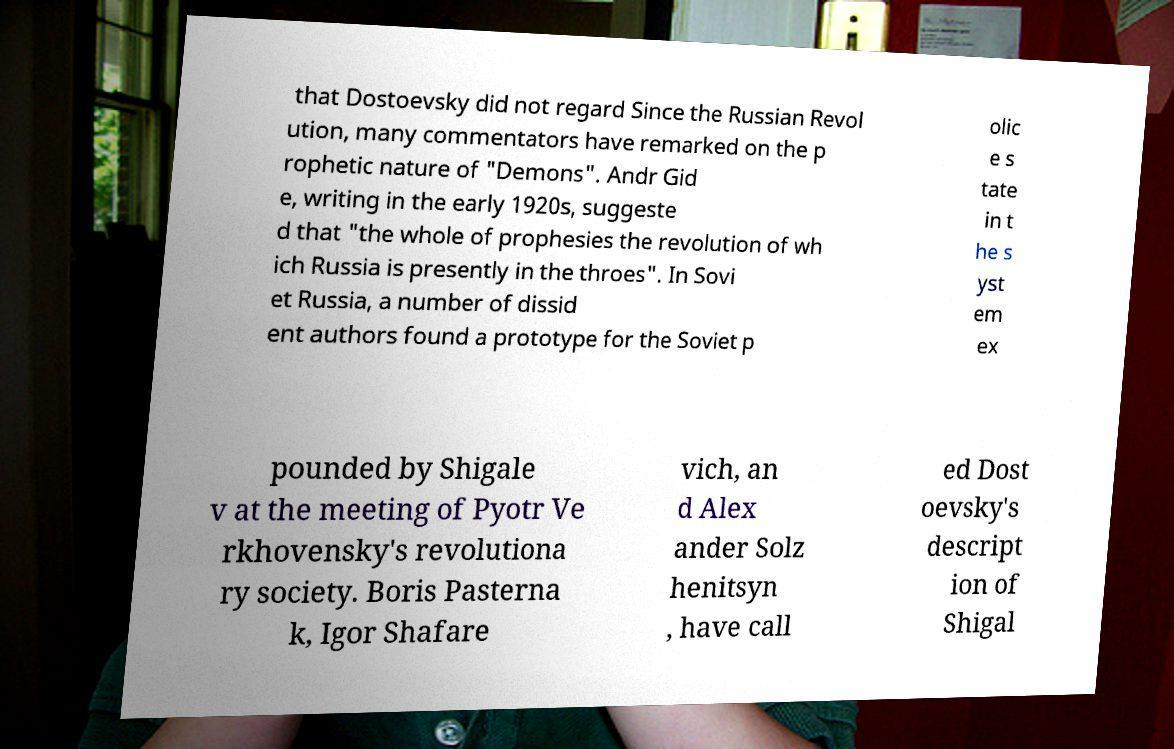Please read and relay the text visible in this image. What does it say? that Dostoevsky did not regard Since the Russian Revol ution, many commentators have remarked on the p rophetic nature of "Demons". Andr Gid e, writing in the early 1920s, suggeste d that "the whole of prophesies the revolution of wh ich Russia is presently in the throes". In Sovi et Russia, a number of dissid ent authors found a prototype for the Soviet p olic e s tate in t he s yst em ex pounded by Shigale v at the meeting of Pyotr Ve rkhovensky's revolutiona ry society. Boris Pasterna k, Igor Shafare vich, an d Alex ander Solz henitsyn , have call ed Dost oevsky's descript ion of Shigal 